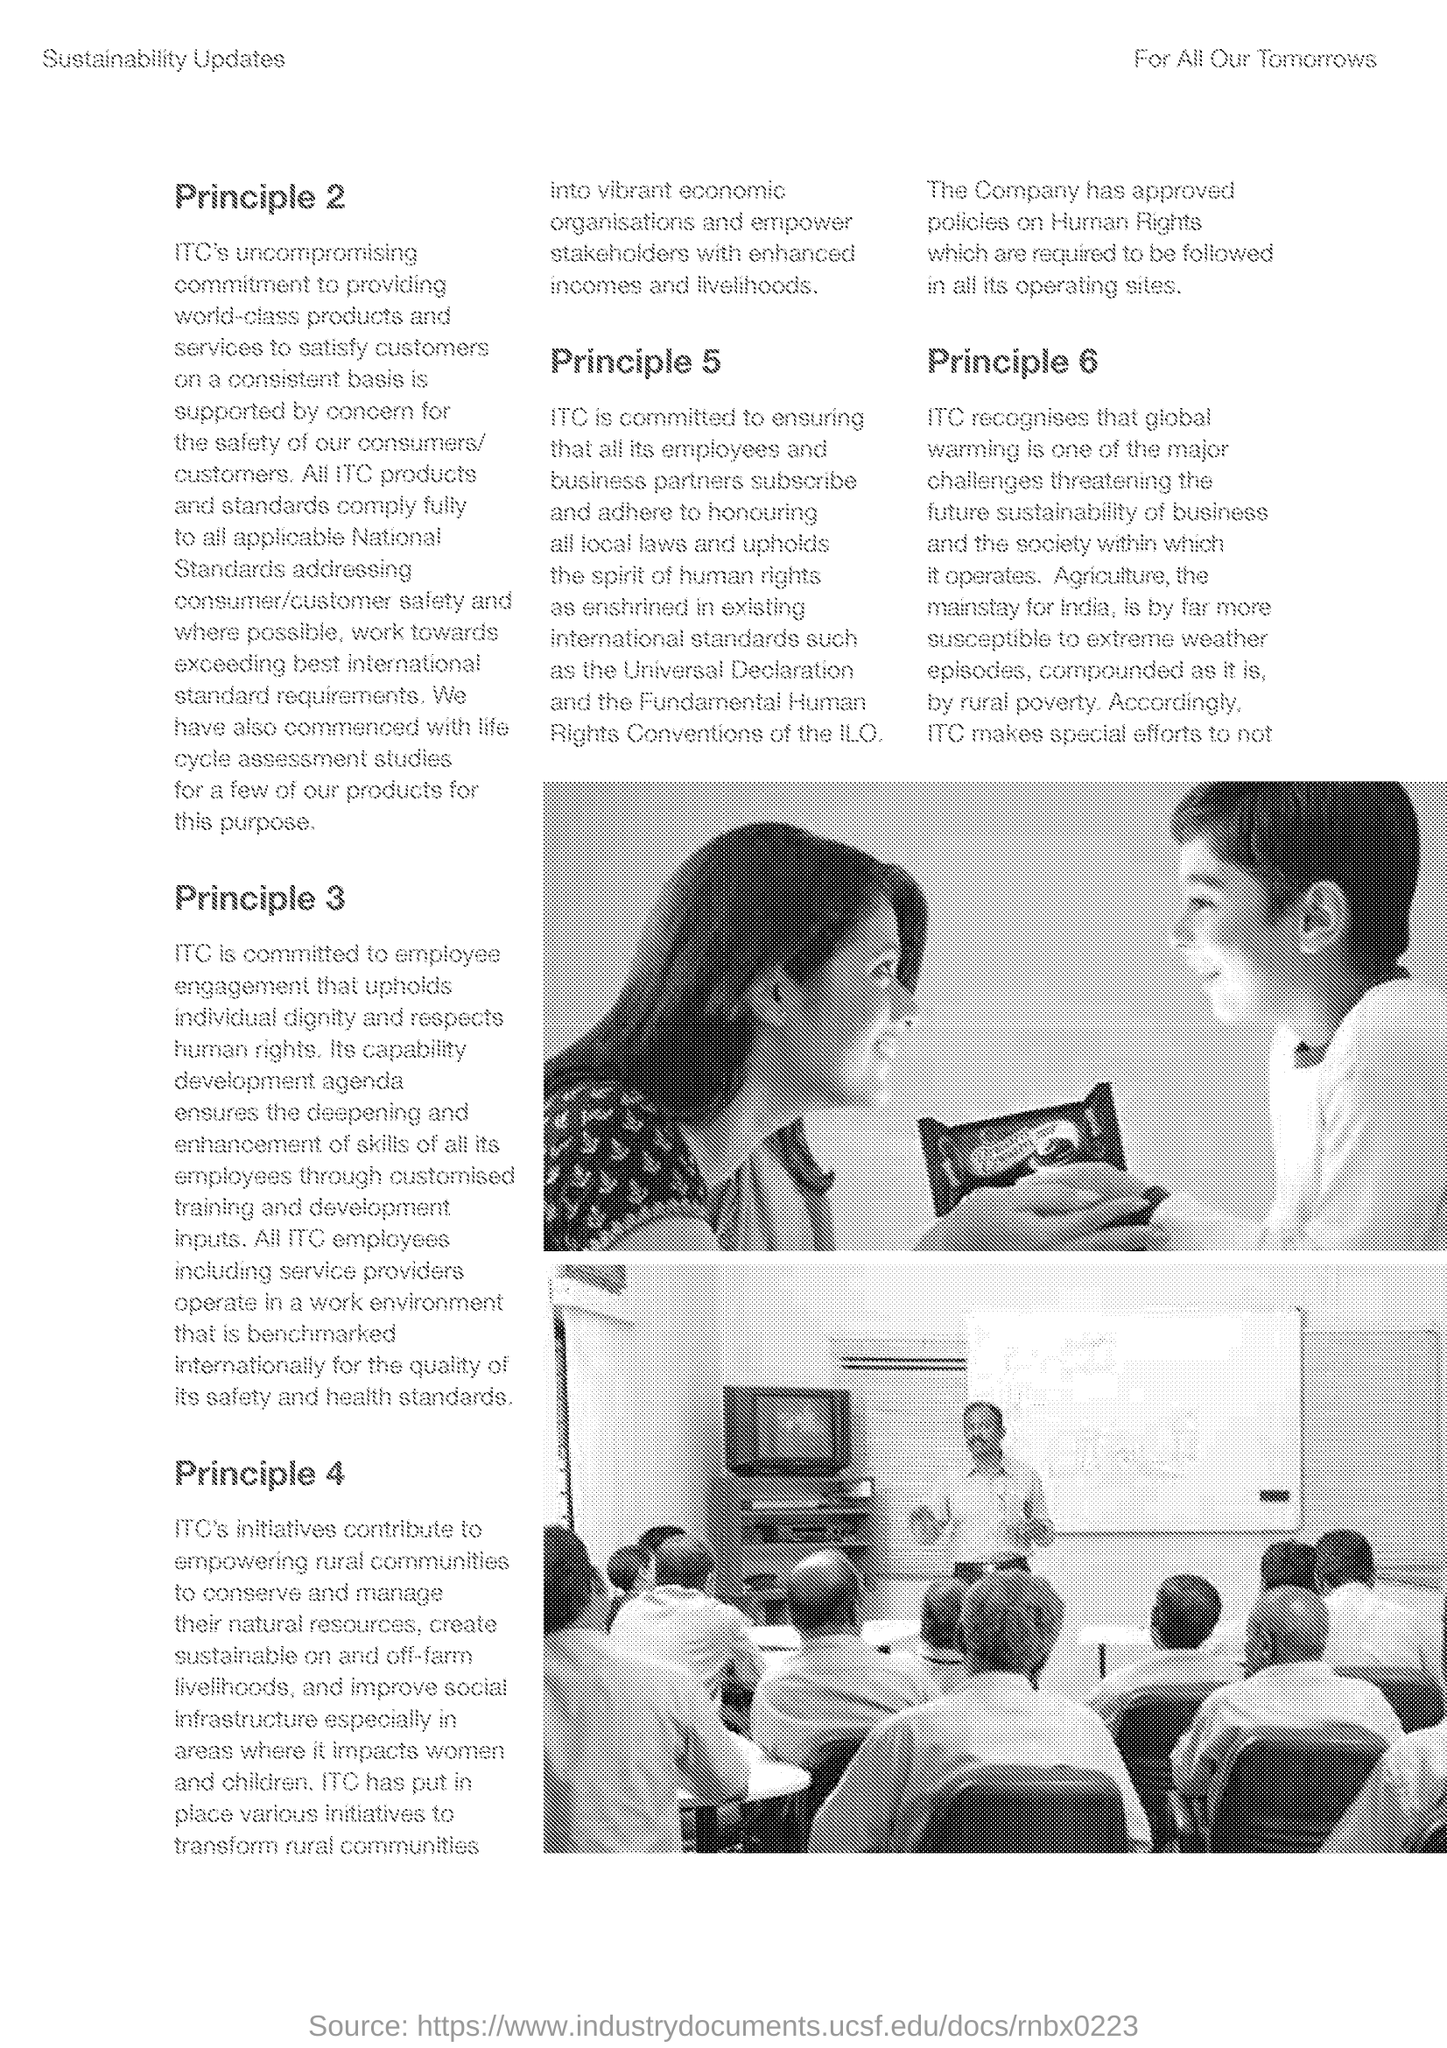What is witten at the left top corner of the page?
Offer a very short reply. Sustainability Updates. What is witten at the right top corner of the page?
Your answer should be compact. FOR ALL OUR TOMORROWS. Which "Principle" is explained in first paragraph of the document  ?
Keep it short and to the point. Principle 2. What kind of "studies" have ITC commenced for few of their products?
Provide a short and direct response. Life cycle assessment studies. According to  which Principle "ITC is committed to employee engagement"?
Give a very brief answer. Principle 3. "ITC's initiatives contribute to empower" which communities?
Provide a short and direct response. Rural communities. Policies on what are approved and " required to be followed in all its operating sites" by the company?
Your answer should be very brief. HUMAN RIGHTS. Which is the last "Principle" mentioned?
Provide a succinct answer. Principle 6. What is "one of the major challenges threatening the future sustainability of business and the society" according to ITC?
Give a very brief answer. Global warming. 